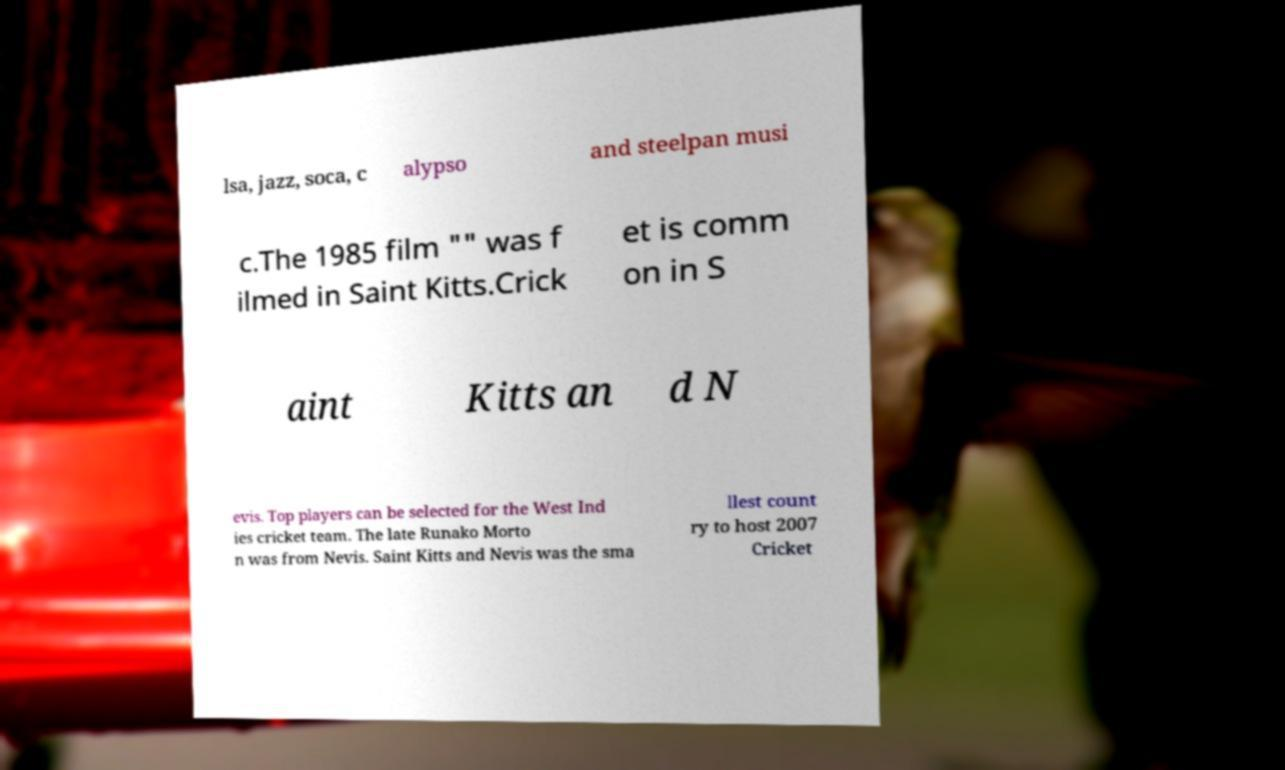Please identify and transcribe the text found in this image. lsa, jazz, soca, c alypso and steelpan musi c.The 1985 film "" was f ilmed in Saint Kitts.Crick et is comm on in S aint Kitts an d N evis. Top players can be selected for the West Ind ies cricket team. The late Runako Morto n was from Nevis. Saint Kitts and Nevis was the sma llest count ry to host 2007 Cricket 